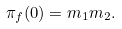Convert formula to latex. <formula><loc_0><loc_0><loc_500><loc_500>\pi _ { f } ( 0 ) = m _ { 1 } m _ { 2 } .</formula> 